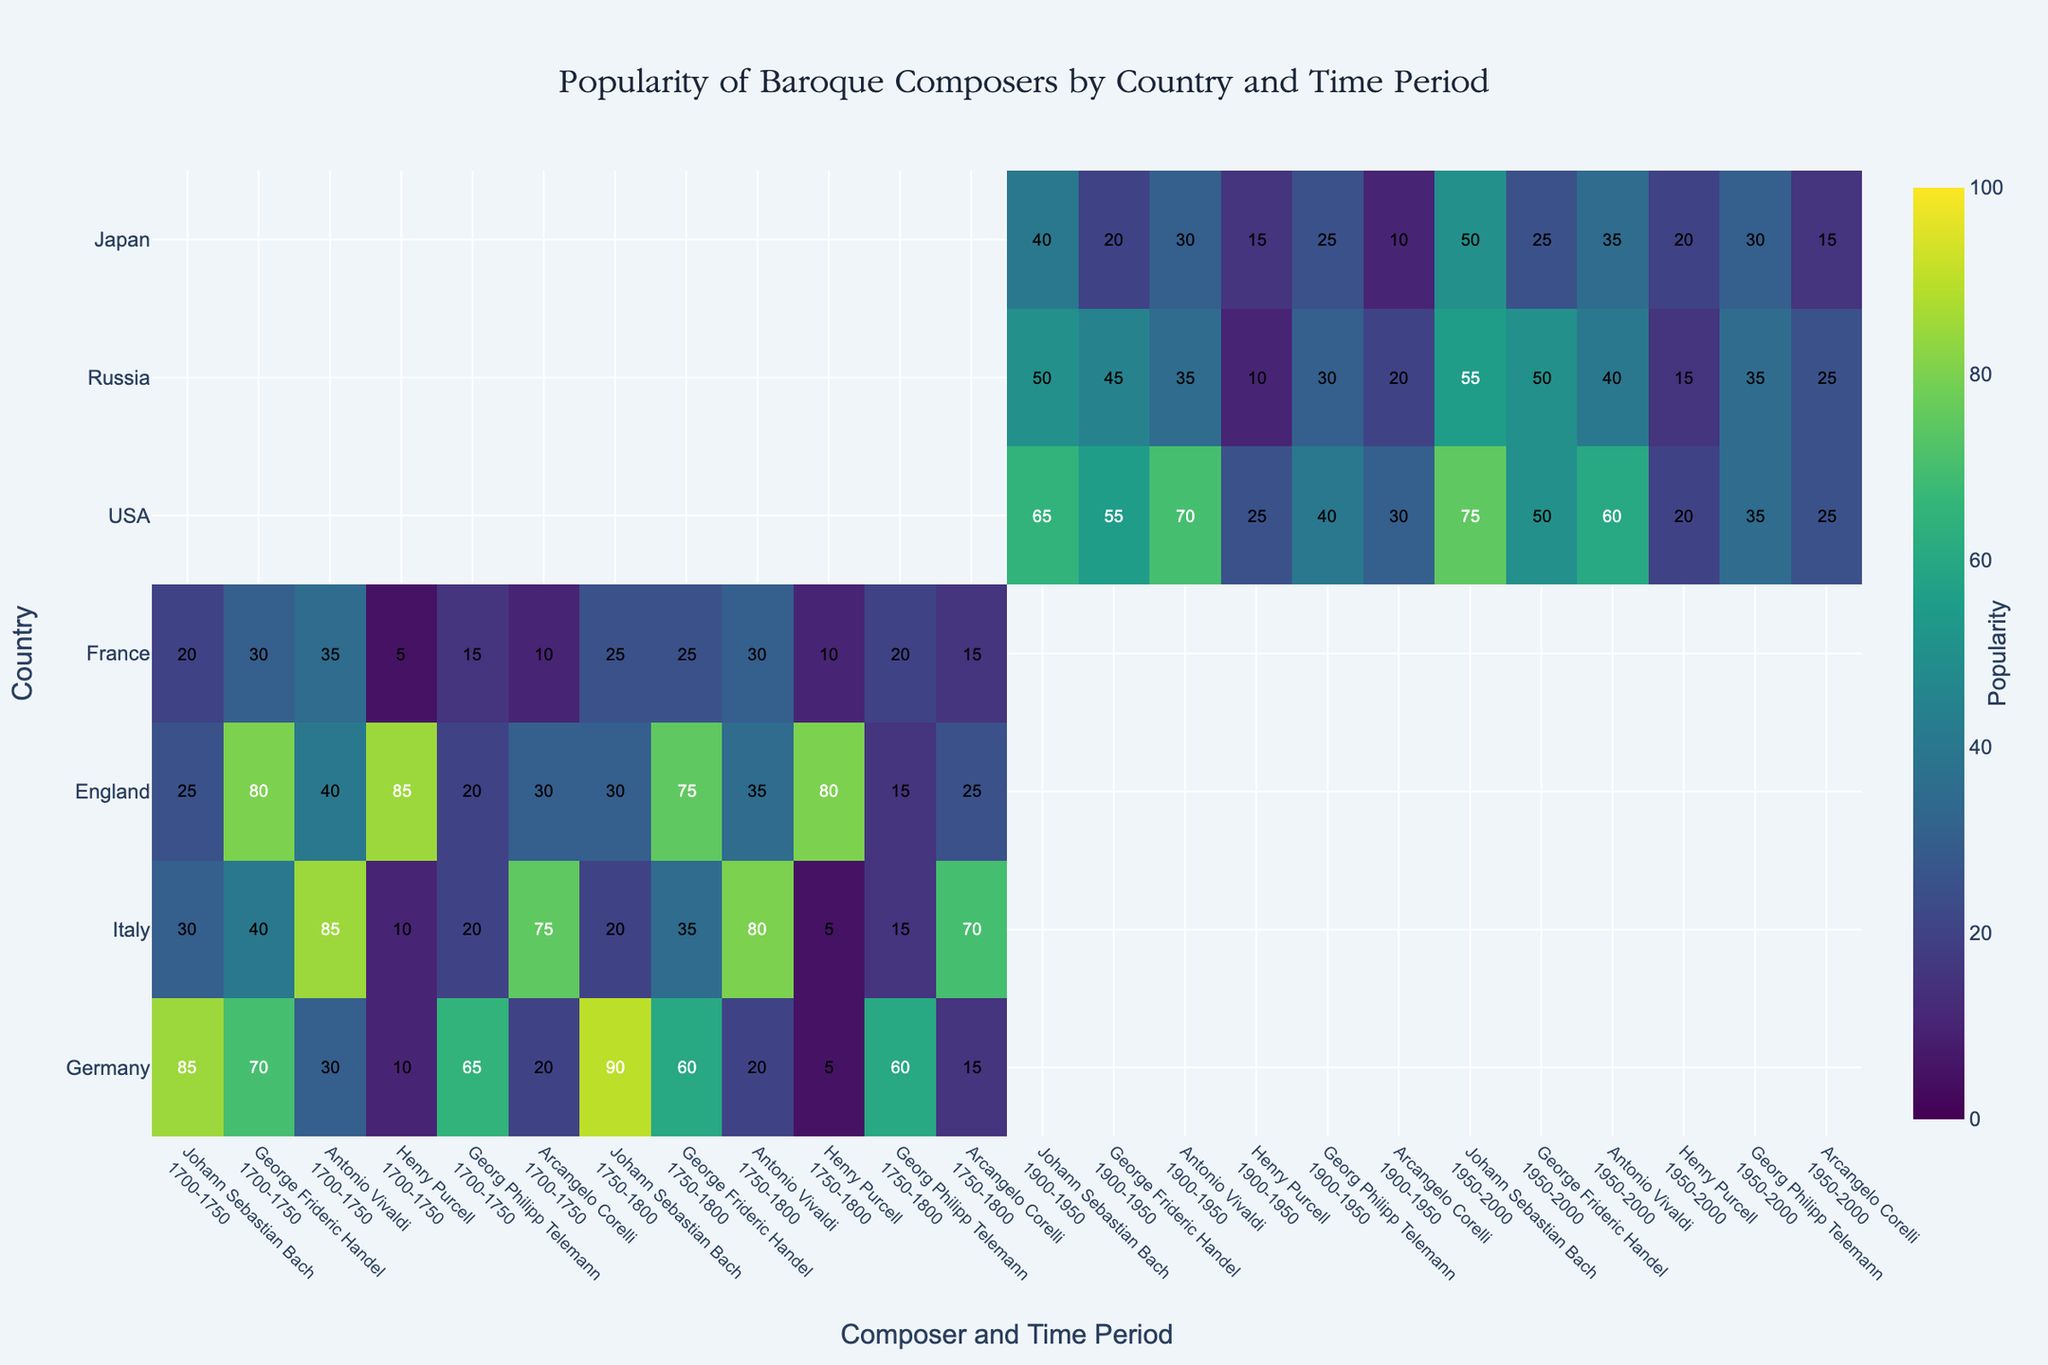Which country shows the highest popularity for Johann Sebastian Bach in the period 1700-1750? Look at the heatmap data for Johann Sebastian Bach across different countries in the period 1700-1750 and identify the highest value.
Answer: Germany Which composer has the highest popularity in Italy during 1700-1750? Check the values for each composer in Italy during the 1700-1750 period and find the highest one.
Answer: Antonio Vivaldi What is the average popularity of George Frideric Handel in Germany across both time periods displayed? Add the popularity values of George Frideric Handel in Germany for 1700-1750 and 1750-1800 and divide by 2 (70 + 60) / 2.
Answer: 65 Which composer in England has a noticeably higher popularity in 1750-1800 compared to 1700-1750? Compare the popularity values of each composer in England between the two periods and identify any significant increase.
Answer: Arcangelo Corelli For France in 1700-1750, who is more popular: Johann Sebastian Bach or Antonio Vivaldi? Compare the popularity values for Johann Sebastian Bach and Antonio Vivaldi in France during 1700-1750.
Answer: Antonio Vivaldi How does the popularity of Henry Purcell in the USA from 1900-1950 compare to his popularity from 1950-2000? Compare the specific values of Henry Purcell’s popularity in the USA for the periods 1900-1950 and 1950-2000.
Answer: Higher in 1900-1950 Which country generally shows the least interest in Baroque composers? Observe the general trend and average of popularity values across all composers and time periods for each country to determine the least interest.
Answer: France How does Japan’s appreciation for Antonio Vivaldi change from 1900-1950 to 1950-2000? Compare the popularity values of Antonio Vivaldi in Japan for these two periods.
Answer: Increases What’s the difference in popularity of Georg Philipp Telemann in Russia between 1900-1950 and 1950-2000? Subtract the popularity value for Georg Philipp Telemann in the period 1900-1950 from his popularity value in 1950-2000.
Answer: 5 Which composer seems to maintain consistent popularity over the years in Germany? Identify if any composer has similar popularity values over the two time periods in Germany.
Answer: Johann Sebastian Bach 